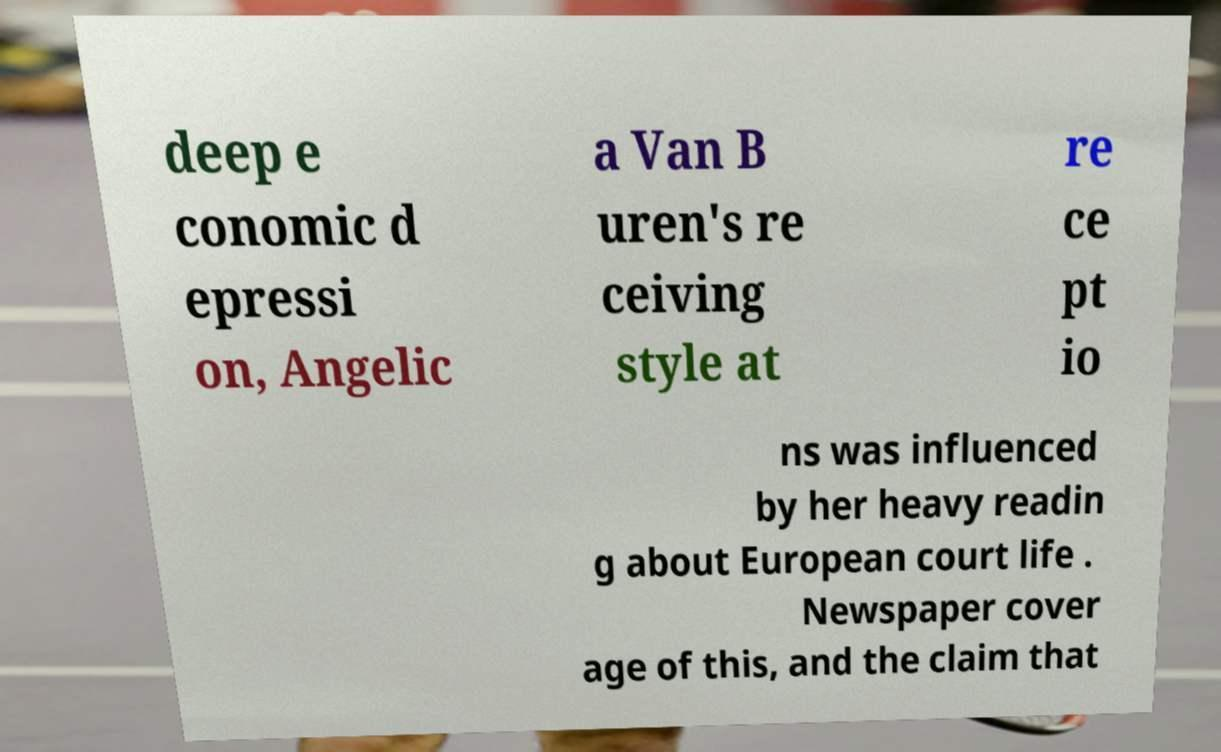Could you assist in decoding the text presented in this image and type it out clearly? deep e conomic d epressi on, Angelic a Van B uren's re ceiving style at re ce pt io ns was influenced by her heavy readin g about European court life . Newspaper cover age of this, and the claim that 